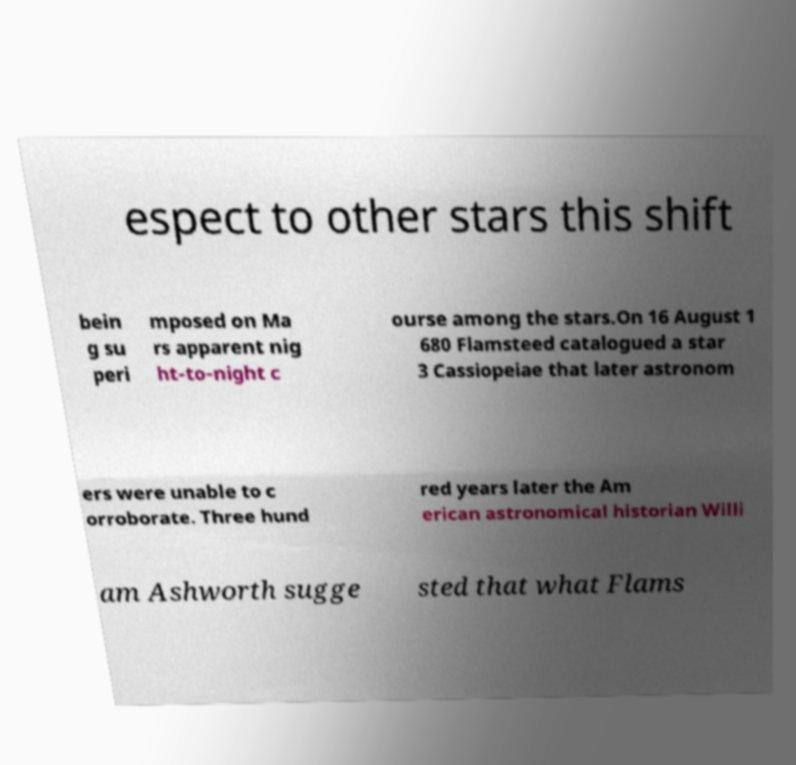Can you accurately transcribe the text from the provided image for me? espect to other stars this shift bein g su peri mposed on Ma rs apparent nig ht-to-night c ourse among the stars.On 16 August 1 680 Flamsteed catalogued a star 3 Cassiopeiae that later astronom ers were unable to c orroborate. Three hund red years later the Am erican astronomical historian Willi am Ashworth sugge sted that what Flams 